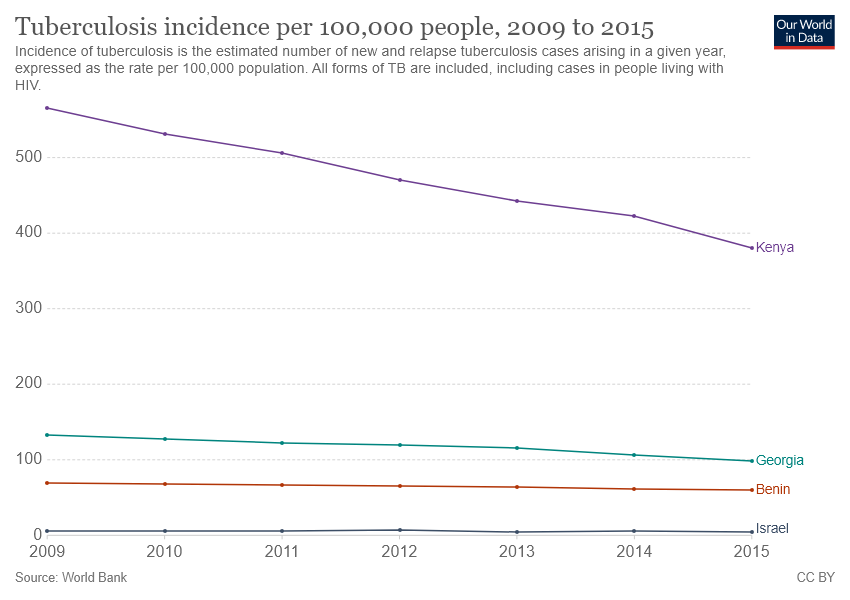Indicate a few pertinent items in this graphic. The average value of all the lines reaches its lowest point in 2015. The green line refers to Georgia. 